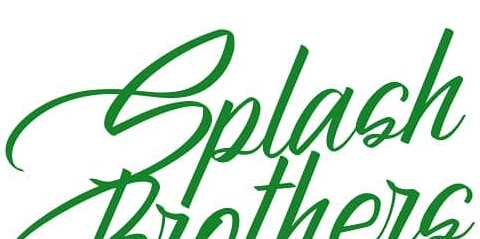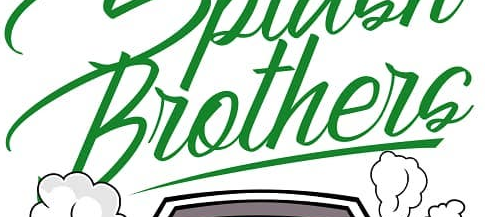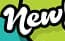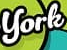Transcribe the words shown in these images in order, separated by a semicolon. Splash; Brothers; New; York 